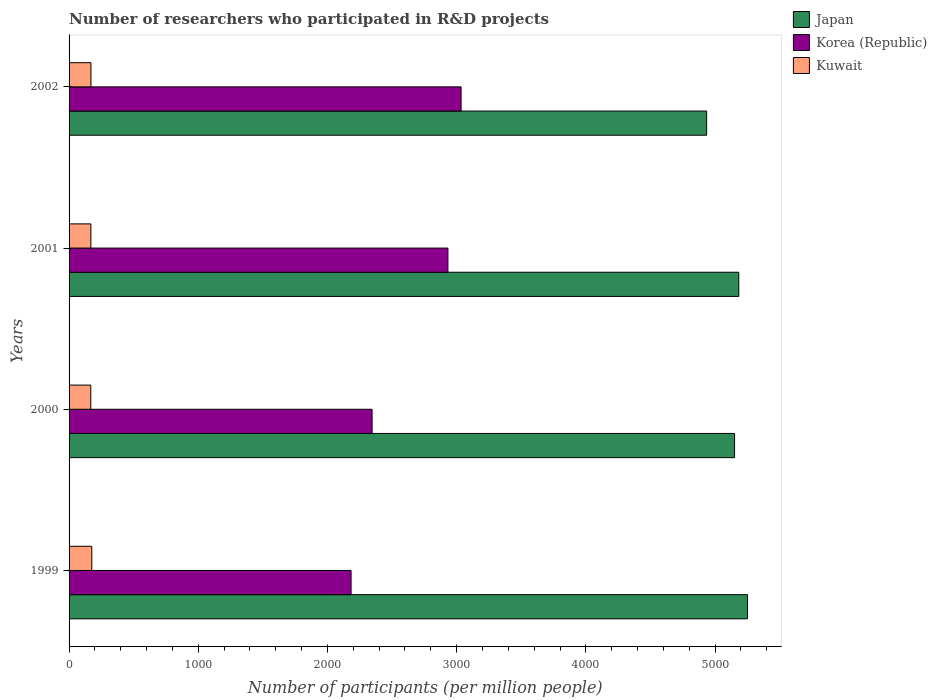How many different coloured bars are there?
Offer a terse response. 3. How many groups of bars are there?
Make the answer very short. 4. Are the number of bars per tick equal to the number of legend labels?
Your response must be concise. Yes. Are the number of bars on each tick of the Y-axis equal?
Offer a very short reply. Yes. How many bars are there on the 1st tick from the top?
Give a very brief answer. 3. What is the number of researchers who participated in R&D projects in Japan in 2002?
Ensure brevity in your answer.  4934.95. Across all years, what is the maximum number of researchers who participated in R&D projects in Japan?
Offer a very short reply. 5251.07. Across all years, what is the minimum number of researchers who participated in R&D projects in Kuwait?
Offer a very short reply. 167.92. In which year was the number of researchers who participated in R&D projects in Kuwait maximum?
Give a very brief answer. 1999. What is the total number of researchers who participated in R&D projects in Korea (Republic) in the graph?
Provide a succinct answer. 1.05e+04. What is the difference between the number of researchers who participated in R&D projects in Kuwait in 2000 and that in 2001?
Your answer should be very brief. -0.92. What is the difference between the number of researchers who participated in R&D projects in Japan in 2000 and the number of researchers who participated in R&D projects in Korea (Republic) in 2001?
Provide a short and direct response. 2218.66. What is the average number of researchers who participated in R&D projects in Japan per year?
Offer a very short reply. 5130.23. In the year 2002, what is the difference between the number of researchers who participated in R&D projects in Japan and number of researchers who participated in R&D projects in Korea (Republic)?
Offer a terse response. 1900.56. What is the ratio of the number of researchers who participated in R&D projects in Korea (Republic) in 2000 to that in 2002?
Your response must be concise. 0.77. What is the difference between the highest and the second highest number of researchers who participated in R&D projects in Korea (Republic)?
Give a very brief answer. 101.92. What is the difference between the highest and the lowest number of researchers who participated in R&D projects in Korea (Republic)?
Provide a short and direct response. 851.56. Is the sum of the number of researchers who participated in R&D projects in Kuwait in 2000 and 2002 greater than the maximum number of researchers who participated in R&D projects in Korea (Republic) across all years?
Ensure brevity in your answer.  No. What does the 1st bar from the top in 1999 represents?
Your answer should be very brief. Kuwait. What does the 2nd bar from the bottom in 2001 represents?
Offer a terse response. Korea (Republic). How many bars are there?
Your answer should be very brief. 12. Are all the bars in the graph horizontal?
Provide a short and direct response. Yes. How many years are there in the graph?
Offer a very short reply. 4. What is the difference between two consecutive major ticks on the X-axis?
Provide a succinct answer. 1000. Does the graph contain any zero values?
Your answer should be very brief. No. Does the graph contain grids?
Keep it short and to the point. No. What is the title of the graph?
Offer a very short reply. Number of researchers who participated in R&D projects. Does "Kuwait" appear as one of the legend labels in the graph?
Offer a very short reply. Yes. What is the label or title of the X-axis?
Your answer should be very brief. Number of participants (per million people). What is the label or title of the Y-axis?
Ensure brevity in your answer.  Years. What is the Number of participants (per million people) of Japan in 1999?
Provide a succinct answer. 5251.07. What is the Number of participants (per million people) in Korea (Republic) in 1999?
Offer a very short reply. 2182.83. What is the Number of participants (per million people) in Kuwait in 1999?
Provide a succinct answer. 175.92. What is the Number of participants (per million people) of Japan in 2000?
Provide a short and direct response. 5151.12. What is the Number of participants (per million people) in Korea (Republic) in 2000?
Provide a succinct answer. 2345.35. What is the Number of participants (per million people) of Kuwait in 2000?
Your answer should be compact. 167.92. What is the Number of participants (per million people) in Japan in 2001?
Offer a terse response. 5183.76. What is the Number of participants (per million people) in Korea (Republic) in 2001?
Offer a very short reply. 2932.46. What is the Number of participants (per million people) of Kuwait in 2001?
Provide a short and direct response. 168.84. What is the Number of participants (per million people) in Japan in 2002?
Offer a terse response. 4934.95. What is the Number of participants (per million people) in Korea (Republic) in 2002?
Provide a short and direct response. 3034.39. What is the Number of participants (per million people) in Kuwait in 2002?
Offer a terse response. 169.42. Across all years, what is the maximum Number of participants (per million people) in Japan?
Provide a succinct answer. 5251.07. Across all years, what is the maximum Number of participants (per million people) in Korea (Republic)?
Your answer should be compact. 3034.39. Across all years, what is the maximum Number of participants (per million people) in Kuwait?
Offer a terse response. 175.92. Across all years, what is the minimum Number of participants (per million people) of Japan?
Ensure brevity in your answer.  4934.95. Across all years, what is the minimum Number of participants (per million people) of Korea (Republic)?
Provide a short and direct response. 2182.83. Across all years, what is the minimum Number of participants (per million people) of Kuwait?
Give a very brief answer. 167.92. What is the total Number of participants (per million people) in Japan in the graph?
Keep it short and to the point. 2.05e+04. What is the total Number of participants (per million people) in Korea (Republic) in the graph?
Provide a short and direct response. 1.05e+04. What is the total Number of participants (per million people) of Kuwait in the graph?
Provide a succinct answer. 682.1. What is the difference between the Number of participants (per million people) in Japan in 1999 and that in 2000?
Offer a terse response. 99.95. What is the difference between the Number of participants (per million people) of Korea (Republic) in 1999 and that in 2000?
Give a very brief answer. -162.52. What is the difference between the Number of participants (per million people) of Kuwait in 1999 and that in 2000?
Ensure brevity in your answer.  7.99. What is the difference between the Number of participants (per million people) in Japan in 1999 and that in 2001?
Your response must be concise. 67.31. What is the difference between the Number of participants (per million people) in Korea (Republic) in 1999 and that in 2001?
Provide a short and direct response. -749.63. What is the difference between the Number of participants (per million people) of Kuwait in 1999 and that in 2001?
Make the answer very short. 7.07. What is the difference between the Number of participants (per million people) in Japan in 1999 and that in 2002?
Your answer should be very brief. 316.12. What is the difference between the Number of participants (per million people) in Korea (Republic) in 1999 and that in 2002?
Offer a very short reply. -851.56. What is the difference between the Number of participants (per million people) in Kuwait in 1999 and that in 2002?
Give a very brief answer. 6.49. What is the difference between the Number of participants (per million people) in Japan in 2000 and that in 2001?
Provide a succinct answer. -32.64. What is the difference between the Number of participants (per million people) of Korea (Republic) in 2000 and that in 2001?
Your answer should be very brief. -587.11. What is the difference between the Number of participants (per million people) in Kuwait in 2000 and that in 2001?
Ensure brevity in your answer.  -0.92. What is the difference between the Number of participants (per million people) in Japan in 2000 and that in 2002?
Your response must be concise. 216.18. What is the difference between the Number of participants (per million people) of Korea (Republic) in 2000 and that in 2002?
Provide a succinct answer. -689.03. What is the difference between the Number of participants (per million people) in Kuwait in 2000 and that in 2002?
Offer a very short reply. -1.5. What is the difference between the Number of participants (per million people) in Japan in 2001 and that in 2002?
Give a very brief answer. 248.81. What is the difference between the Number of participants (per million people) in Korea (Republic) in 2001 and that in 2002?
Make the answer very short. -101.92. What is the difference between the Number of participants (per million people) in Kuwait in 2001 and that in 2002?
Offer a very short reply. -0.58. What is the difference between the Number of participants (per million people) of Japan in 1999 and the Number of participants (per million people) of Korea (Republic) in 2000?
Give a very brief answer. 2905.72. What is the difference between the Number of participants (per million people) of Japan in 1999 and the Number of participants (per million people) of Kuwait in 2000?
Ensure brevity in your answer.  5083.15. What is the difference between the Number of participants (per million people) of Korea (Republic) in 1999 and the Number of participants (per million people) of Kuwait in 2000?
Your answer should be compact. 2014.91. What is the difference between the Number of participants (per million people) of Japan in 1999 and the Number of participants (per million people) of Korea (Republic) in 2001?
Ensure brevity in your answer.  2318.61. What is the difference between the Number of participants (per million people) of Japan in 1999 and the Number of participants (per million people) of Kuwait in 2001?
Your answer should be very brief. 5082.23. What is the difference between the Number of participants (per million people) of Korea (Republic) in 1999 and the Number of participants (per million people) of Kuwait in 2001?
Your answer should be very brief. 2013.99. What is the difference between the Number of participants (per million people) in Japan in 1999 and the Number of participants (per million people) in Korea (Republic) in 2002?
Offer a very short reply. 2216.68. What is the difference between the Number of participants (per million people) of Japan in 1999 and the Number of participants (per million people) of Kuwait in 2002?
Keep it short and to the point. 5081.65. What is the difference between the Number of participants (per million people) of Korea (Republic) in 1999 and the Number of participants (per million people) of Kuwait in 2002?
Your answer should be very brief. 2013.41. What is the difference between the Number of participants (per million people) of Japan in 2000 and the Number of participants (per million people) of Korea (Republic) in 2001?
Give a very brief answer. 2218.66. What is the difference between the Number of participants (per million people) in Japan in 2000 and the Number of participants (per million people) in Kuwait in 2001?
Offer a very short reply. 4982.28. What is the difference between the Number of participants (per million people) of Korea (Republic) in 2000 and the Number of participants (per million people) of Kuwait in 2001?
Give a very brief answer. 2176.51. What is the difference between the Number of participants (per million people) in Japan in 2000 and the Number of participants (per million people) in Korea (Republic) in 2002?
Give a very brief answer. 2116.74. What is the difference between the Number of participants (per million people) in Japan in 2000 and the Number of participants (per million people) in Kuwait in 2002?
Keep it short and to the point. 4981.7. What is the difference between the Number of participants (per million people) of Korea (Republic) in 2000 and the Number of participants (per million people) of Kuwait in 2002?
Provide a succinct answer. 2175.93. What is the difference between the Number of participants (per million people) in Japan in 2001 and the Number of participants (per million people) in Korea (Republic) in 2002?
Your response must be concise. 2149.38. What is the difference between the Number of participants (per million people) of Japan in 2001 and the Number of participants (per million people) of Kuwait in 2002?
Provide a succinct answer. 5014.34. What is the difference between the Number of participants (per million people) in Korea (Republic) in 2001 and the Number of participants (per million people) in Kuwait in 2002?
Provide a short and direct response. 2763.04. What is the average Number of participants (per million people) in Japan per year?
Your answer should be very brief. 5130.23. What is the average Number of participants (per million people) in Korea (Republic) per year?
Provide a short and direct response. 2623.76. What is the average Number of participants (per million people) in Kuwait per year?
Your answer should be very brief. 170.53. In the year 1999, what is the difference between the Number of participants (per million people) of Japan and Number of participants (per million people) of Korea (Republic)?
Provide a short and direct response. 3068.24. In the year 1999, what is the difference between the Number of participants (per million people) in Japan and Number of participants (per million people) in Kuwait?
Offer a very short reply. 5075.16. In the year 1999, what is the difference between the Number of participants (per million people) of Korea (Republic) and Number of participants (per million people) of Kuwait?
Offer a very short reply. 2006.91. In the year 2000, what is the difference between the Number of participants (per million people) of Japan and Number of participants (per million people) of Korea (Republic)?
Ensure brevity in your answer.  2805.77. In the year 2000, what is the difference between the Number of participants (per million people) of Japan and Number of participants (per million people) of Kuwait?
Provide a short and direct response. 4983.2. In the year 2000, what is the difference between the Number of participants (per million people) of Korea (Republic) and Number of participants (per million people) of Kuwait?
Your response must be concise. 2177.43. In the year 2001, what is the difference between the Number of participants (per million people) in Japan and Number of participants (per million people) in Korea (Republic)?
Offer a terse response. 2251.3. In the year 2001, what is the difference between the Number of participants (per million people) in Japan and Number of participants (per million people) in Kuwait?
Offer a very short reply. 5014.92. In the year 2001, what is the difference between the Number of participants (per million people) of Korea (Republic) and Number of participants (per million people) of Kuwait?
Offer a very short reply. 2763.62. In the year 2002, what is the difference between the Number of participants (per million people) in Japan and Number of participants (per million people) in Korea (Republic)?
Offer a terse response. 1900.56. In the year 2002, what is the difference between the Number of participants (per million people) of Japan and Number of participants (per million people) of Kuwait?
Offer a terse response. 4765.53. In the year 2002, what is the difference between the Number of participants (per million people) of Korea (Republic) and Number of participants (per million people) of Kuwait?
Offer a very short reply. 2864.96. What is the ratio of the Number of participants (per million people) in Japan in 1999 to that in 2000?
Keep it short and to the point. 1.02. What is the ratio of the Number of participants (per million people) of Korea (Republic) in 1999 to that in 2000?
Ensure brevity in your answer.  0.93. What is the ratio of the Number of participants (per million people) of Kuwait in 1999 to that in 2000?
Offer a terse response. 1.05. What is the ratio of the Number of participants (per million people) in Japan in 1999 to that in 2001?
Provide a succinct answer. 1.01. What is the ratio of the Number of participants (per million people) of Korea (Republic) in 1999 to that in 2001?
Give a very brief answer. 0.74. What is the ratio of the Number of participants (per million people) of Kuwait in 1999 to that in 2001?
Make the answer very short. 1.04. What is the ratio of the Number of participants (per million people) of Japan in 1999 to that in 2002?
Your answer should be very brief. 1.06. What is the ratio of the Number of participants (per million people) in Korea (Republic) in 1999 to that in 2002?
Keep it short and to the point. 0.72. What is the ratio of the Number of participants (per million people) of Kuwait in 1999 to that in 2002?
Provide a short and direct response. 1.04. What is the ratio of the Number of participants (per million people) of Korea (Republic) in 2000 to that in 2001?
Your answer should be compact. 0.8. What is the ratio of the Number of participants (per million people) of Japan in 2000 to that in 2002?
Ensure brevity in your answer.  1.04. What is the ratio of the Number of participants (per million people) of Korea (Republic) in 2000 to that in 2002?
Your answer should be very brief. 0.77. What is the ratio of the Number of participants (per million people) in Kuwait in 2000 to that in 2002?
Keep it short and to the point. 0.99. What is the ratio of the Number of participants (per million people) in Japan in 2001 to that in 2002?
Your answer should be very brief. 1.05. What is the ratio of the Number of participants (per million people) in Korea (Republic) in 2001 to that in 2002?
Your answer should be very brief. 0.97. What is the ratio of the Number of participants (per million people) in Kuwait in 2001 to that in 2002?
Give a very brief answer. 1. What is the difference between the highest and the second highest Number of participants (per million people) of Japan?
Keep it short and to the point. 67.31. What is the difference between the highest and the second highest Number of participants (per million people) in Korea (Republic)?
Offer a terse response. 101.92. What is the difference between the highest and the second highest Number of participants (per million people) in Kuwait?
Provide a short and direct response. 6.49. What is the difference between the highest and the lowest Number of participants (per million people) in Japan?
Provide a succinct answer. 316.12. What is the difference between the highest and the lowest Number of participants (per million people) in Korea (Republic)?
Make the answer very short. 851.56. What is the difference between the highest and the lowest Number of participants (per million people) in Kuwait?
Make the answer very short. 7.99. 